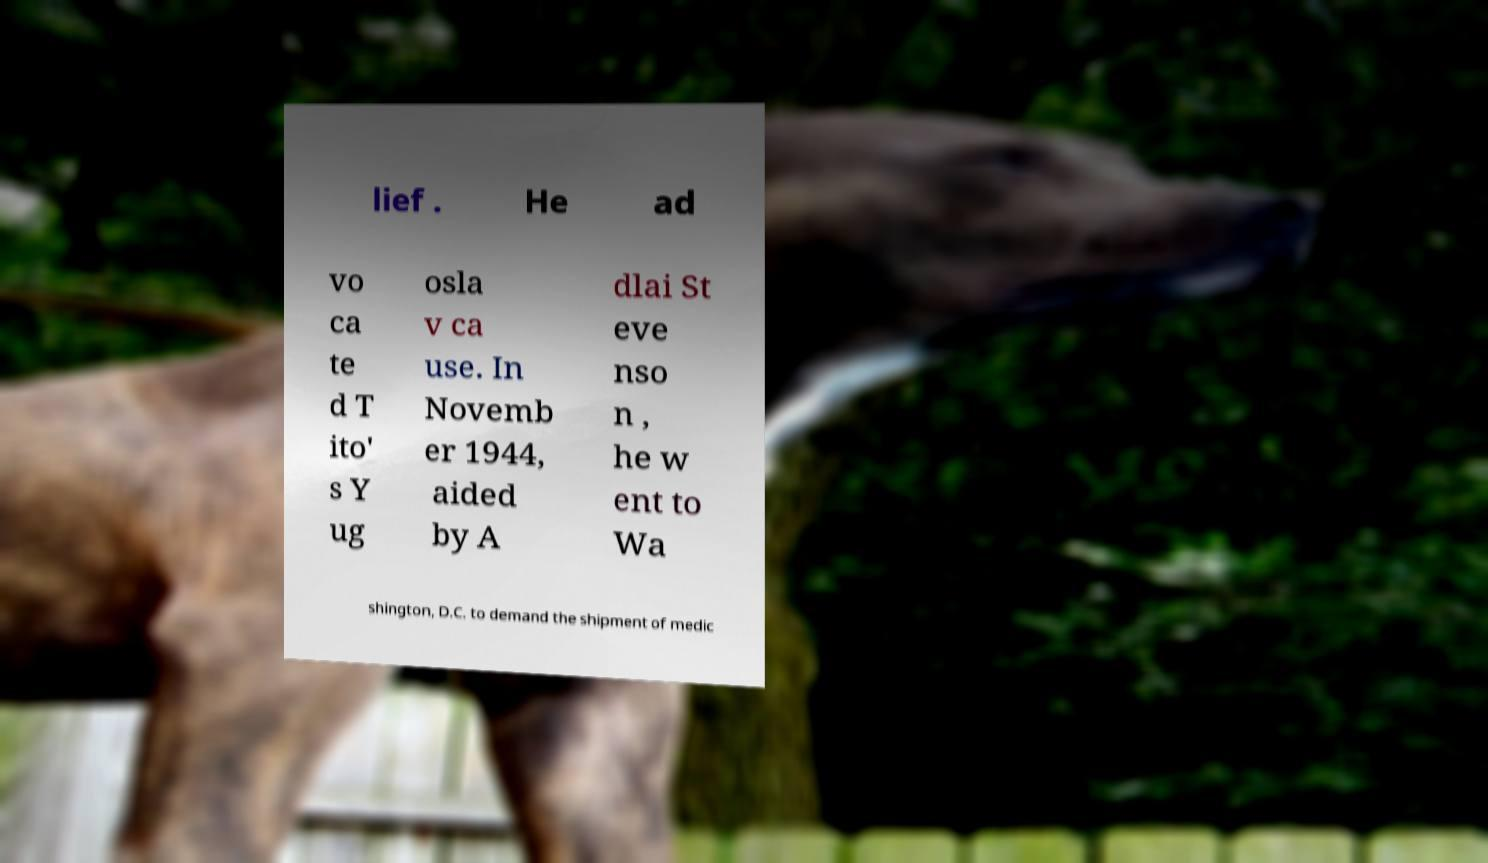I need the written content from this picture converted into text. Can you do that? lief . He ad vo ca te d T ito' s Y ug osla v ca use. In Novemb er 1944, aided by A dlai St eve nso n , he w ent to Wa shington, D.C. to demand the shipment of medic 